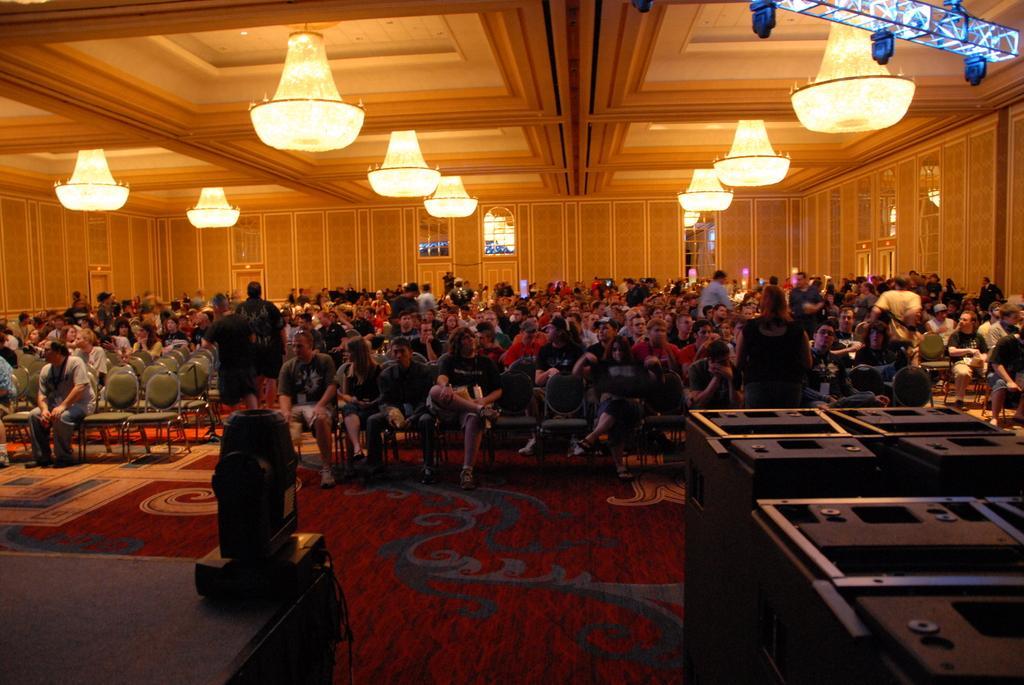Describe this image in one or two sentences. In this image we can see a group of people are sitting on the chairs, here a woman is standing on the floor, at above here is the chandelier, here is the light, here is the wall. 